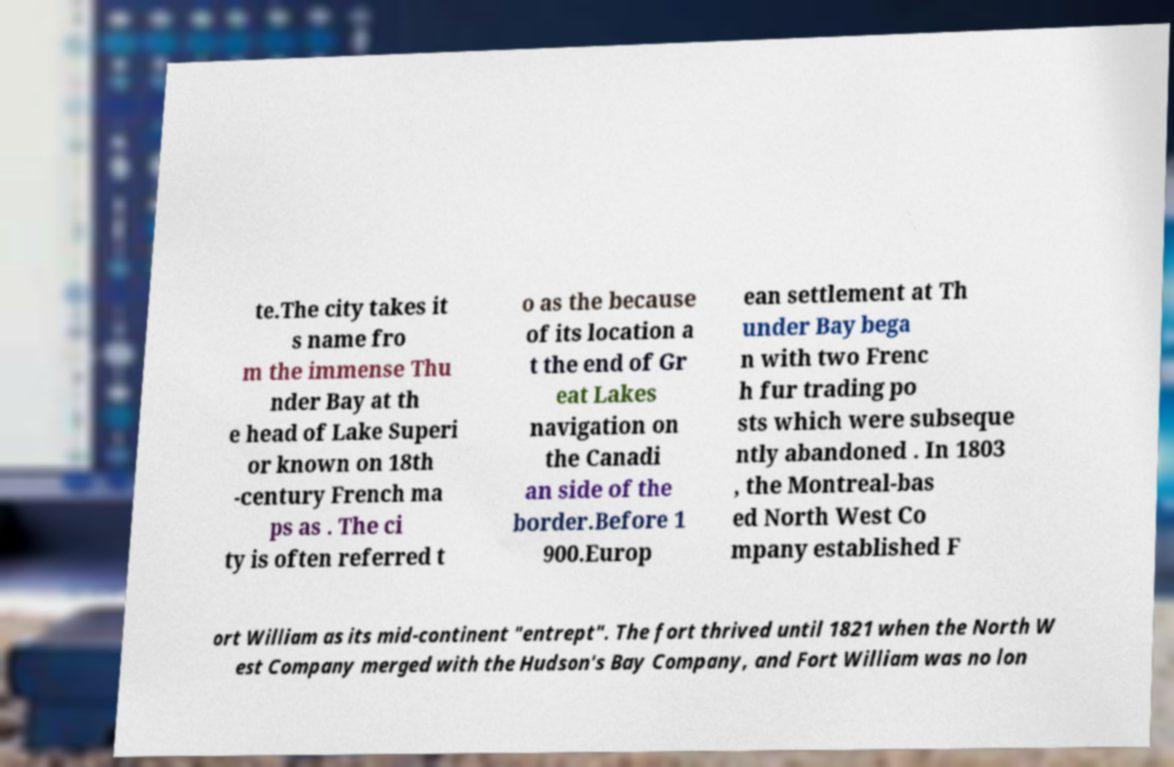Can you accurately transcribe the text from the provided image for me? te.The city takes it s name fro m the immense Thu nder Bay at th e head of Lake Superi or known on 18th -century French ma ps as . The ci ty is often referred t o as the because of its location a t the end of Gr eat Lakes navigation on the Canadi an side of the border.Before 1 900.Europ ean settlement at Th under Bay bega n with two Frenc h fur trading po sts which were subseque ntly abandoned . In 1803 , the Montreal-bas ed North West Co mpany established F ort William as its mid-continent "entrept". The fort thrived until 1821 when the North W est Company merged with the Hudson's Bay Company, and Fort William was no lon 